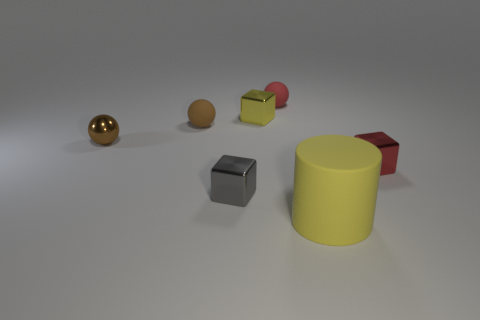Add 1 big gray blocks. How many objects exist? 8 Subtract all red blocks. How many blocks are left? 2 Subtract all blue blocks. How many brown spheres are left? 2 Subtract all red spheres. How many spheres are left? 2 Subtract all purple blocks. Subtract all purple spheres. How many blocks are left? 3 Subtract all purple spheres. Subtract all metal cubes. How many objects are left? 4 Add 6 shiny objects. How many shiny objects are left? 10 Add 2 large rubber cylinders. How many large rubber cylinders exist? 3 Subtract 0 blue cylinders. How many objects are left? 7 Subtract all blocks. How many objects are left? 4 